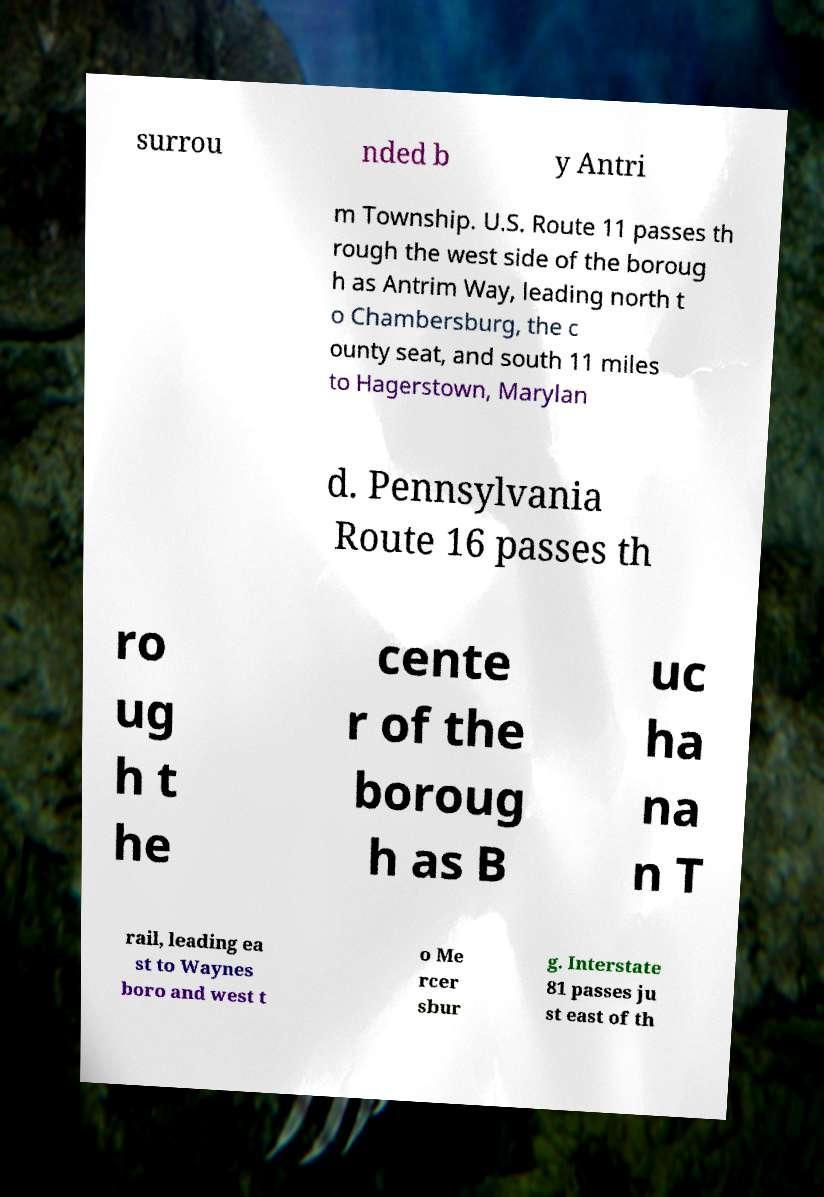Could you extract and type out the text from this image? surrou nded b y Antri m Township. U.S. Route 11 passes th rough the west side of the boroug h as Antrim Way, leading north t o Chambersburg, the c ounty seat, and south 11 miles to Hagerstown, Marylan d. Pennsylvania Route 16 passes th ro ug h t he cente r of the boroug h as B uc ha na n T rail, leading ea st to Waynes boro and west t o Me rcer sbur g. Interstate 81 passes ju st east of th 